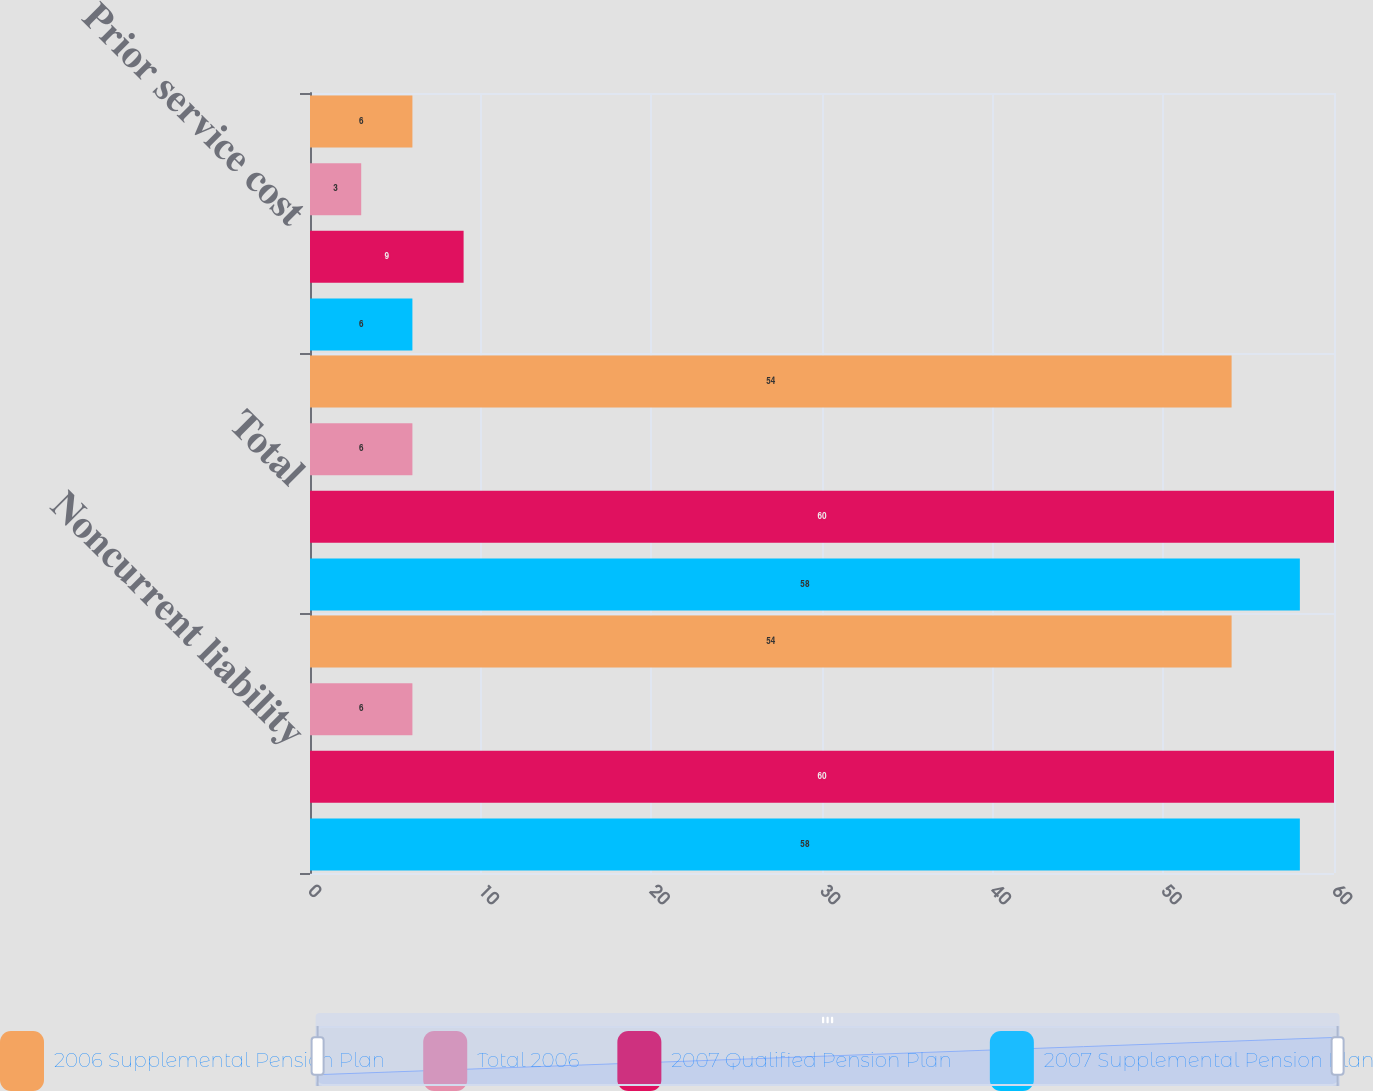Convert chart to OTSL. <chart><loc_0><loc_0><loc_500><loc_500><stacked_bar_chart><ecel><fcel>Noncurrent liability<fcel>Total<fcel>Prior service cost<nl><fcel>2006 Supplemental Pension Plan<fcel>54<fcel>54<fcel>6<nl><fcel>Total 2006<fcel>6<fcel>6<fcel>3<nl><fcel>2007 Qualified Pension Plan<fcel>60<fcel>60<fcel>9<nl><fcel>2007 Supplemental Pension Plan<fcel>58<fcel>58<fcel>6<nl></chart> 